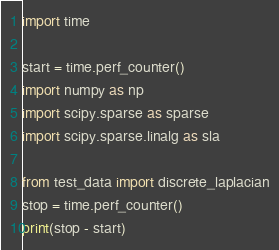<code> <loc_0><loc_0><loc_500><loc_500><_Python_>import time

start = time.perf_counter()
import numpy as np
import scipy.sparse as sparse
import scipy.sparse.linalg as sla

from test_data import discrete_laplacian
stop = time.perf_counter()
print(stop - start)

</code> 